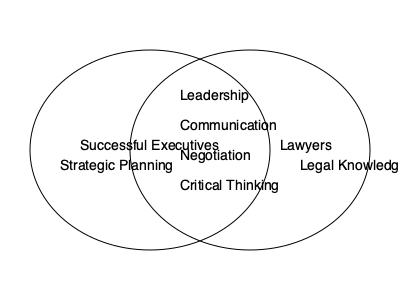Based on the Venn diagram illustrating overlapping skills between successful executives and lawyers, how many shared skills are depicted in the intersection? To answer this question, we need to analyze the Venn diagram carefully:

1. The diagram shows two overlapping circles, one representing "Successful Executives" and the other representing "Lawyers."

2. In the overlapping area (intersection) of the two circles, we can see four distinct skills listed:
   a) Leadership
   b) Communication
   c) Negotiation
   d) Critical Thinking

3. These four skills are positioned in the intersection, indicating that they are common to both successful executives and lawyers.

4. Outside the intersection, we can see "Strategic Planning" on the executives' side and "Legal Knowledge" on the lawyers' side, but these are not shared skills.

5. Therefore, the number of shared skills depicted in the intersection of the Venn diagram is 4.

This visualization challenges the persona's doubt about the importance of debate skills in the legal profession by highlighting the significant overlap in key competencies between executives and lawyers, particularly in areas related to communication and critical thinking.
Answer: 4 